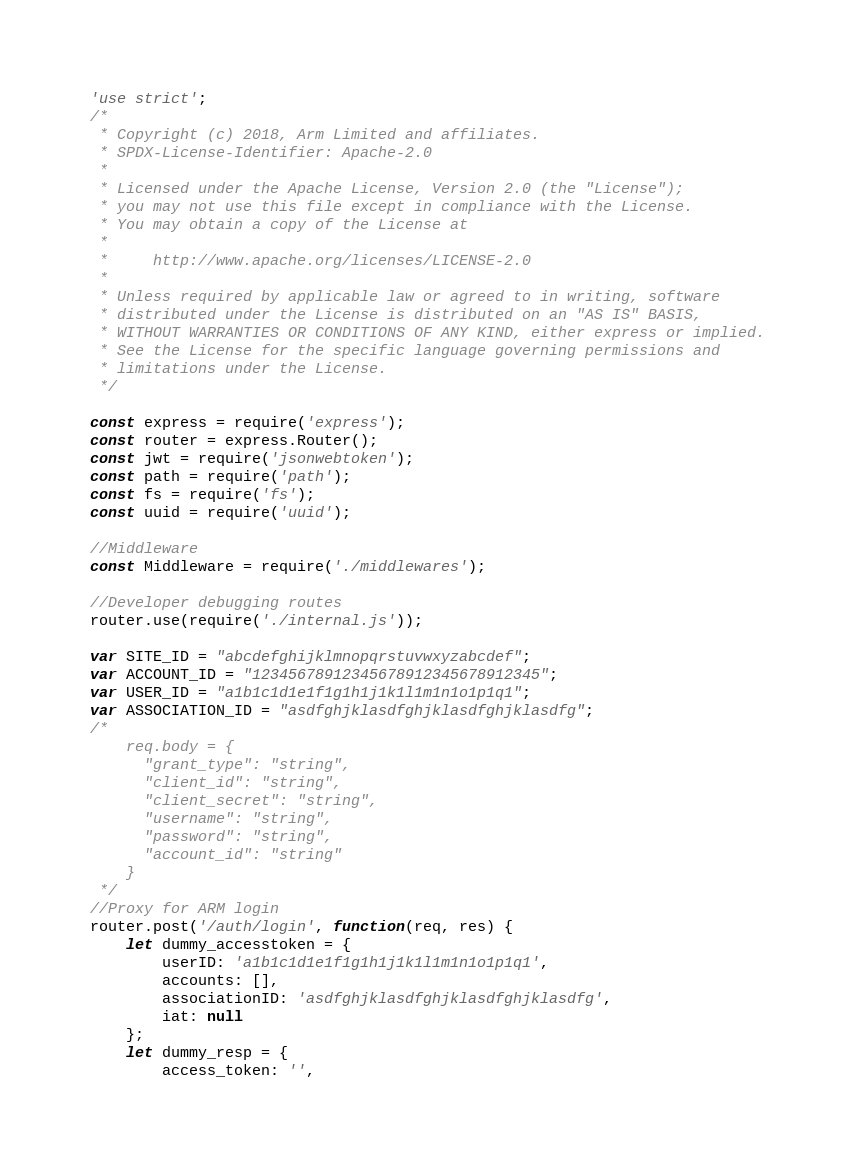Convert code to text. <code><loc_0><loc_0><loc_500><loc_500><_JavaScript_>'use strict';
/*
 * Copyright (c) 2018, Arm Limited and affiliates.
 * SPDX-License-Identifier: Apache-2.0
 *
 * Licensed under the Apache License, Version 2.0 (the "License");
 * you may not use this file except in compliance with the License.
 * You may obtain a copy of the License at
 *
 *     http://www.apache.org/licenses/LICENSE-2.0
 *
 * Unless required by applicable law or agreed to in writing, software
 * distributed under the License is distributed on an "AS IS" BASIS,
 * WITHOUT WARRANTIES OR CONDITIONS OF ANY KIND, either express or implied.
 * See the License for the specific language governing permissions and
 * limitations under the License.
 */

const express = require('express');
const router = express.Router();
const jwt = require('jsonwebtoken');
const path = require('path');
const fs = require('fs');
const uuid = require('uuid');

//Middleware
const Middleware = require('./middlewares');

//Developer debugging routes
router.use(require('./internal.js'));

var SITE_ID = "abcdefghijklmnopqrstuvwxyzabcdef";
var ACCOUNT_ID = "12345678912345678912345678912345";
var USER_ID = "a1b1c1d1e1f1g1h1j1k1l1m1n1o1p1q1";
var ASSOCIATION_ID = "asdfghjklasdfghjklasdfghjklasdfg";
/*
    req.body = {
      "grant_type": "string",
      "client_id": "string",
      "client_secret": "string",
      "username": "string",
      "password": "string",
      "account_id": "string"
    }
 */
//Proxy for ARM login
router.post('/auth/login', function(req, res) {
    let dummy_accesstoken = {
        userID: 'a1b1c1d1e1f1g1h1j1k1l1m1n1o1p1q1',
        accounts: [],
        associationID: 'asdfghjklasdfghjklasdfghjklasdfg',
        iat: null
    };
    let dummy_resp = {
        access_token: '',</code> 